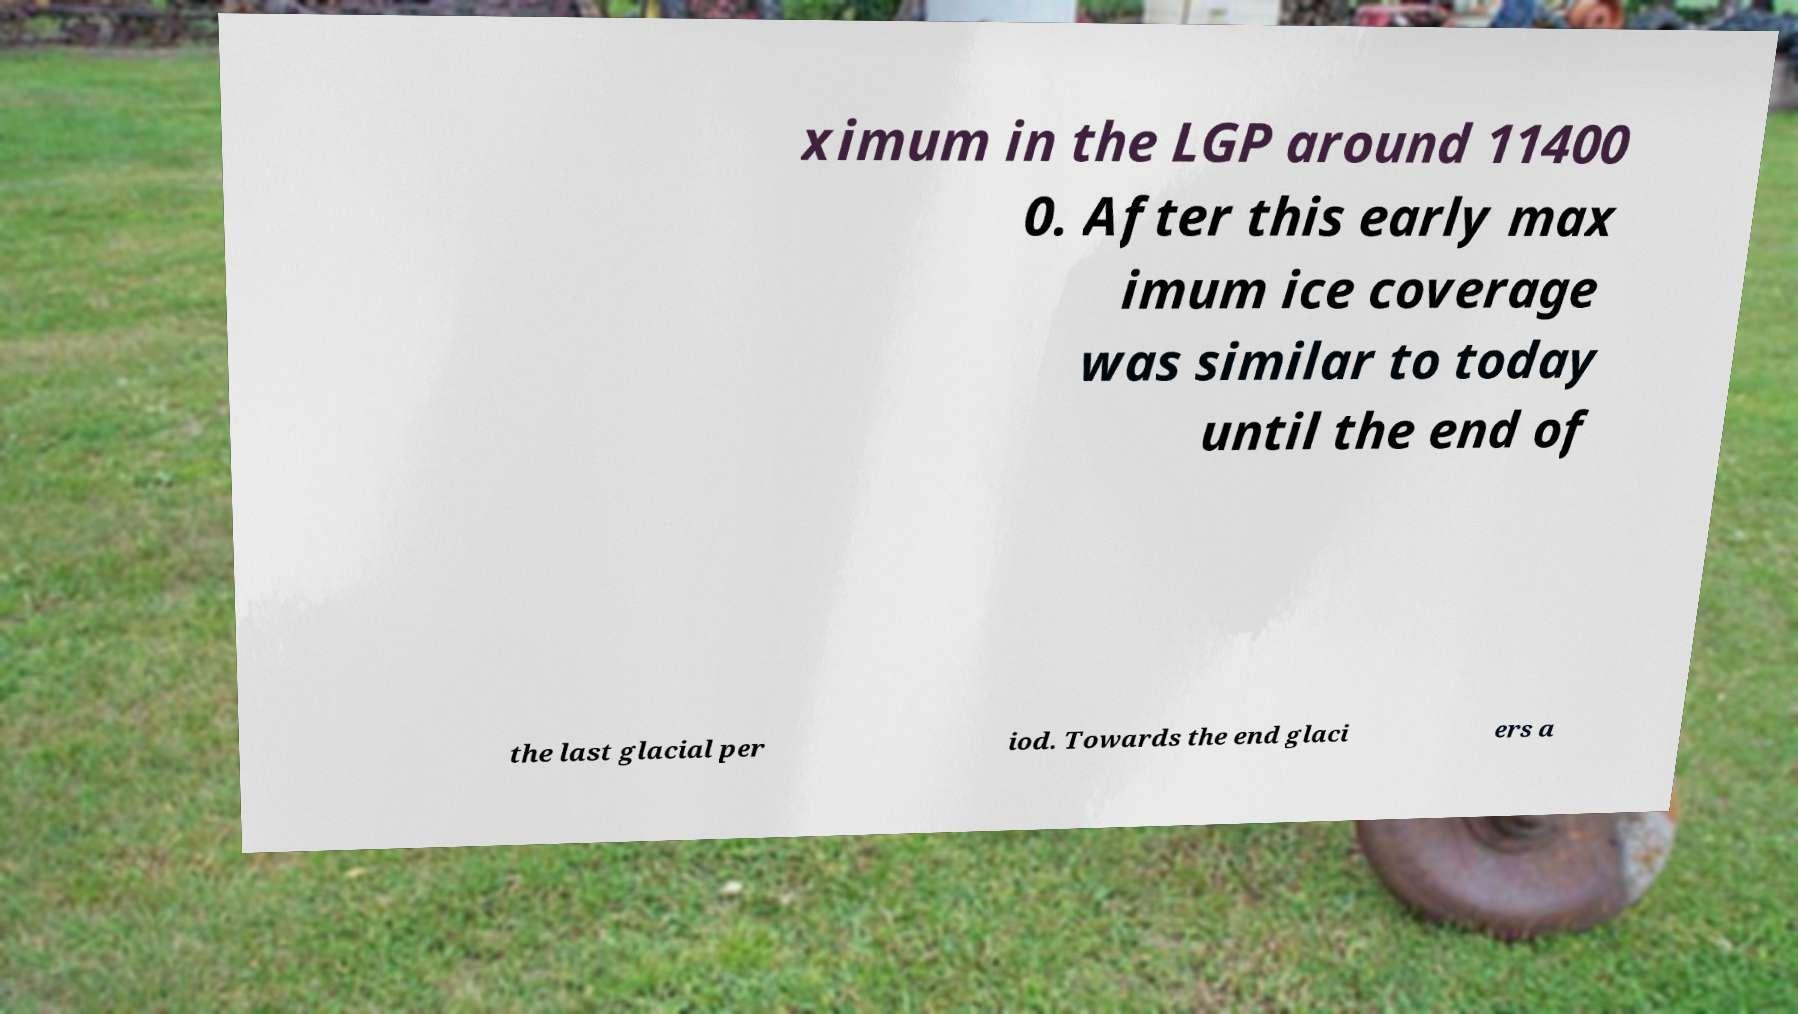Can you accurately transcribe the text from the provided image for me? ximum in the LGP around 11400 0. After this early max imum ice coverage was similar to today until the end of the last glacial per iod. Towards the end glaci ers a 